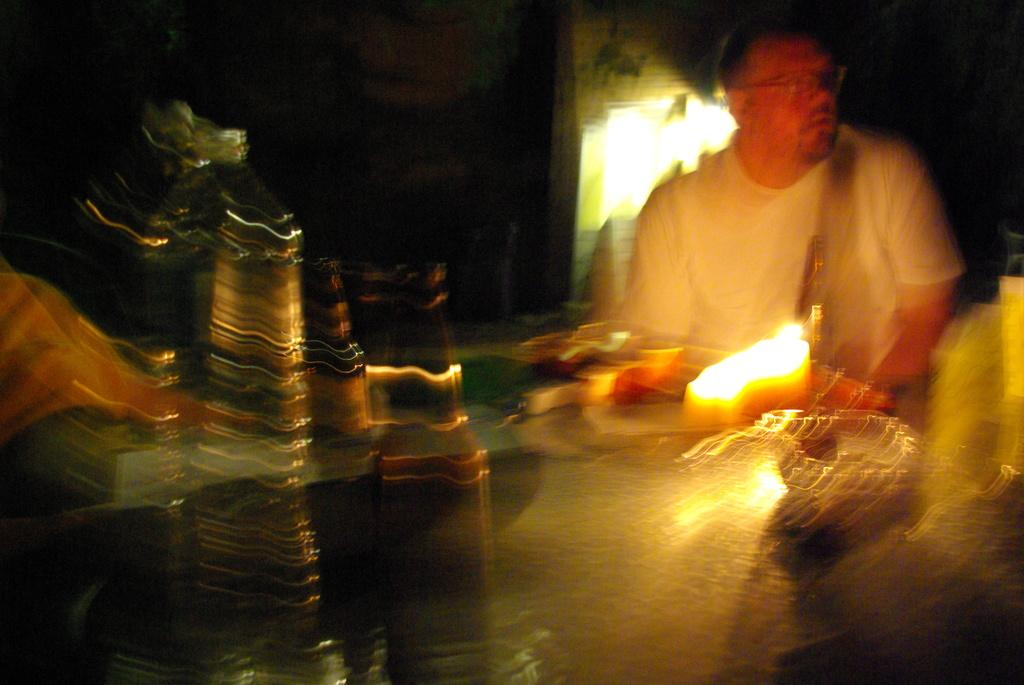What is the man in the image doing? The man is seated in the image. What objects are on the table in the image? There are bottles and a bowl on the table in the image. What type of illumination is present on the table? There is light on the table in the image. What can be seen in the background of the image? There is light on the back (presumably referring to the background) in the image. What question does the man ask in the image? There is no indication in the image that the man is asking a question. 